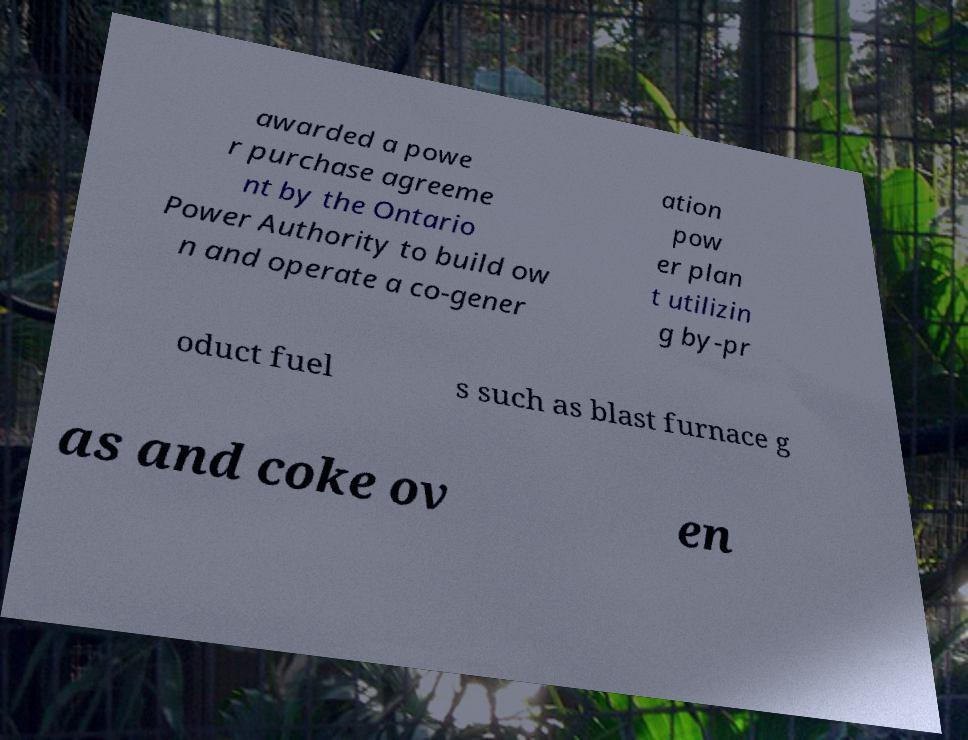Could you assist in decoding the text presented in this image and type it out clearly? awarded a powe r purchase agreeme nt by the Ontario Power Authority to build ow n and operate a co-gener ation pow er plan t utilizin g by-pr oduct fuel s such as blast furnace g as and coke ov en 